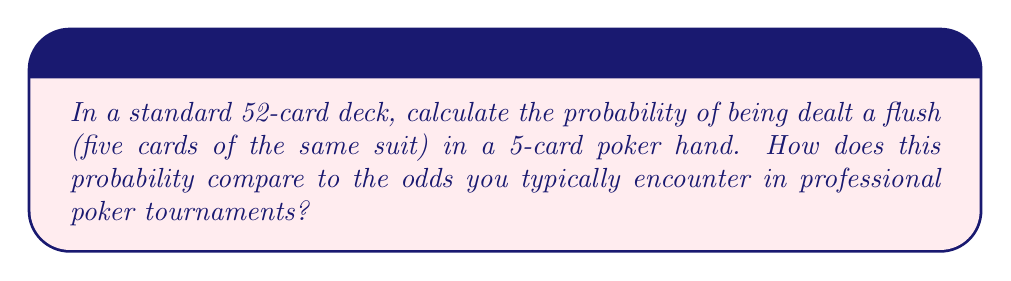Teach me how to tackle this problem. Let's approach this step-by-step using combinatorics:

1) First, we need to calculate the total number of possible 5-card hands from a 52-card deck. This is given by the combination formula:

   $$\binom{52}{5} = \frac{52!}{5!(52-5)!} = 2,598,960$$

2) Now, to calculate the number of possible flush hands:
   a) Choose one of the 4 suits: $\binom{4}{1}$
   b) Choose 5 cards from the 13 cards of that suit: $\binom{13}{5}$

3) The total number of flush hands is:

   $$4 \cdot \binom{13}{5} = 4 \cdot \frac{13!}{5!(13-5)!} = 4 \cdot 1,287 = 5,148$$

4) The probability of being dealt a flush is:

   $$P(\text{Flush}) = \frac{\text{Number of flush hands}}{\text{Total number of possible hands}} = \frac{5,148}{2,598,960} \approx 0.001981$$

5) This can be expressed as a percentage:

   $$0.001981 \cdot 100\% \approx 0.1981\%$$

6) In odds notation, this is approximately 504:1 against being dealt a flush.

As a professional poker player, you would recognize that this probability is quite low compared to the odds typically encountered in tournaments. In tournament play, the probabilities of interest are often related to the likelihood of improving your hand on the turn or river, or the odds of your hand holding up against opponents' possible holdings, which are generally much higher than the probability of being dealt a specific made hand like a flush.
Answer: The probability of being dealt a flush in a 5-card poker hand is approximately 0.1981% or 504:1 against. 